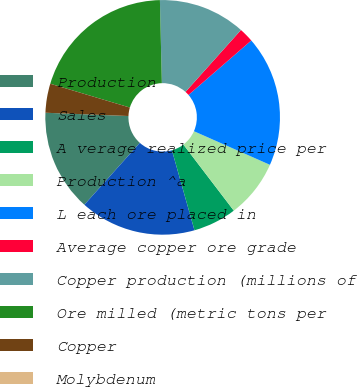Convert chart to OTSL. <chart><loc_0><loc_0><loc_500><loc_500><pie_chart><fcel>Production<fcel>Sales<fcel>A verage realized price per<fcel>Production ^a<fcel>L each ore placed in<fcel>Average copper ore grade<fcel>Copper production (millions of<fcel>Ore milled (metric tons per<fcel>Copper<fcel>Molybdenum<nl><fcel>14.0%<fcel>16.0%<fcel>6.0%<fcel>8.0%<fcel>18.0%<fcel>2.0%<fcel>12.0%<fcel>20.0%<fcel>4.0%<fcel>0.0%<nl></chart> 